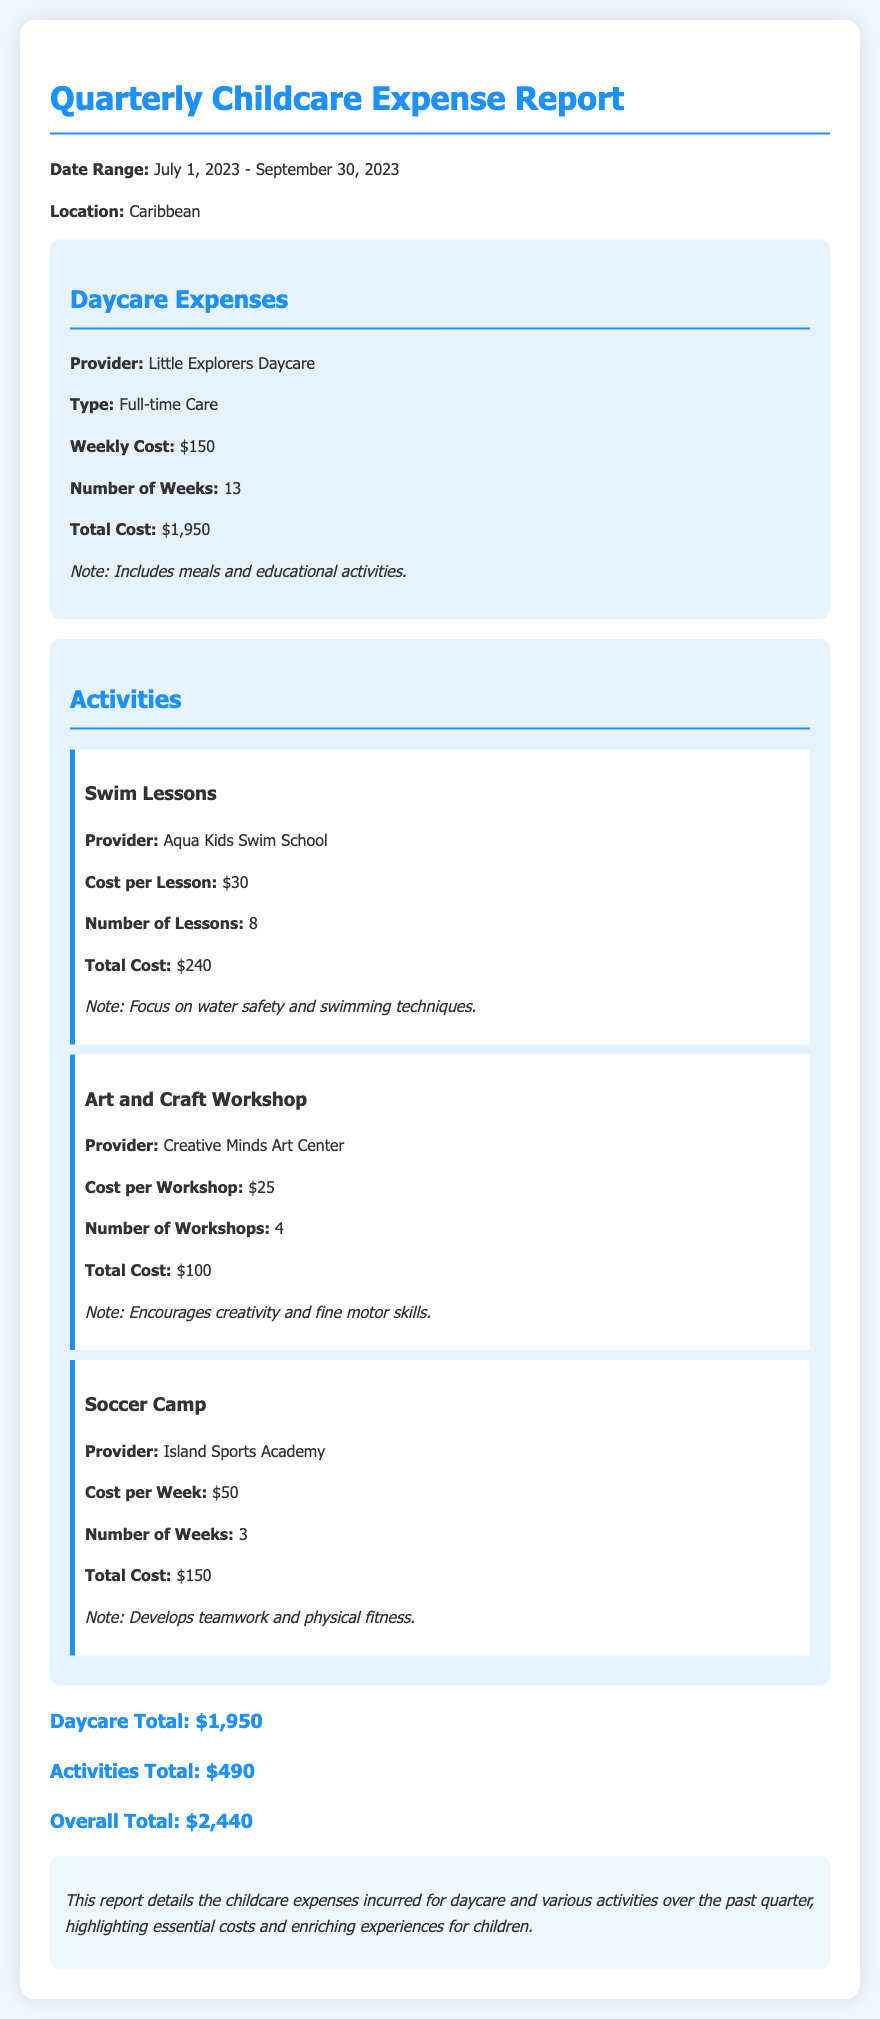What is the name of the daycare provider? The daycare provider mentioned in the document is "Little Explorers Daycare."
Answer: Little Explorers Daycare What is the total cost for daycare? The total cost for daycare over the quarter is listed as $1,950.
Answer: $1,950 How many swim lessons were taken? The document states that there were 8 swim lessons taken.
Answer: 8 What is the cost per workshop for the Art and Craft Workshop? The cost per workshop for the Art and Craft Workshop is $25.
Answer: $25 What is the overall total of all childcare expenses? The overall total of all childcare expenses is $2,440, as calculated from daycare and activities.
Answer: $2,440 How many weeks of Soccer Camp were attended? The document indicates that 3 weeks of Soccer Camp were attended.
Answer: 3 What is the total cost for activities? The total cost for activities, as per the document, is $490.
Answer: $490 What type of care is provided by the daycare? The document specifies that the type of care provided is "Full-time Care."
Answer: Full-time Care What is highlighted as an important feature in the Swim Lessons? The Swim Lessons focus on "water safety and swimming techniques."
Answer: water safety and swimming techniques 